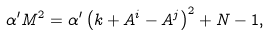<formula> <loc_0><loc_0><loc_500><loc_500>\alpha ^ { \prime } M ^ { 2 } = \alpha ^ { \prime } \left ( k + A ^ { i } - A ^ { j } \right ) ^ { 2 } + N - 1 ,</formula> 